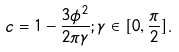<formula> <loc_0><loc_0><loc_500><loc_500>c = 1 - \frac { 3 \phi ^ { 2 } } { 2 \pi \gamma } ; \gamma \in [ 0 , \frac { \pi } { 2 } ] .</formula> 